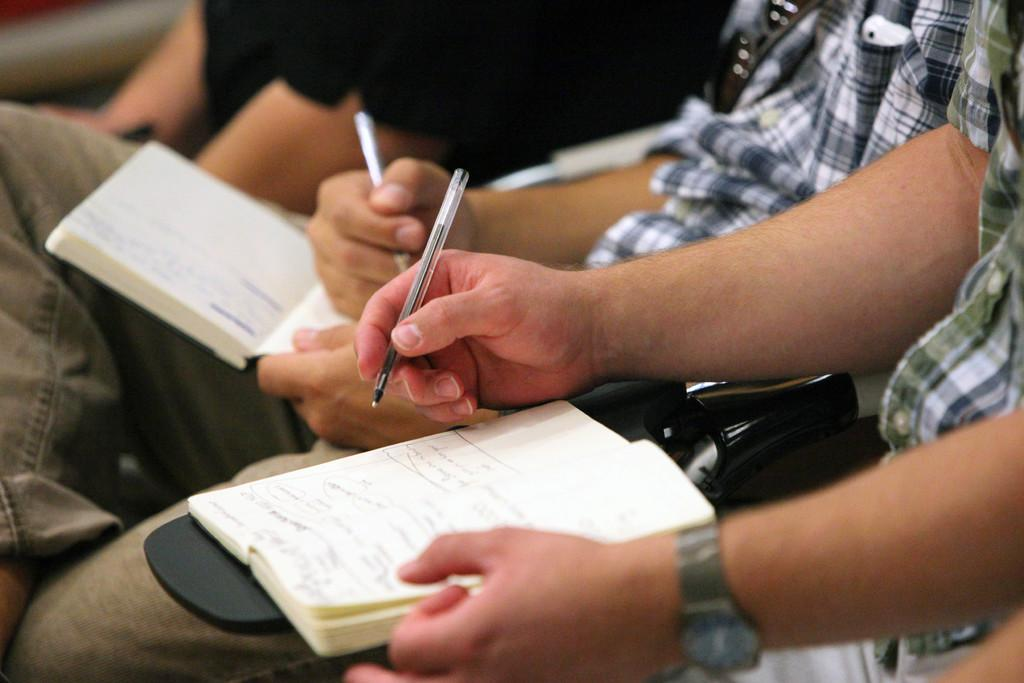How many people are in the image? There are two persons in the image. What are the persons holding in their hands? Both persons are holding books and pens. Can you describe any unique feature of one of the persons? One of the men is wearing goggles. What is near one of the men? There is an unspecified object near one of the men. Can you describe the person at the top of the image? There is another person at the top of the image, but no specific details are provided. What type of teaching is the person at the top of the image conducting? There is no indication in the image that the person at the top of the image is conducting any teaching. What is the desire of the person wearing goggles in the image? There is no information about the desires of the person wearing goggles in the image. 